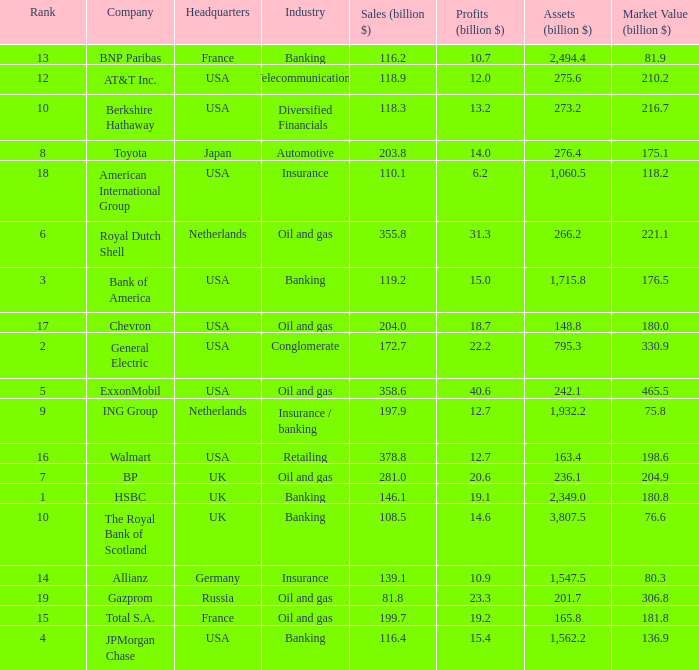What is the highest rank of a company that has 1,715.8 billion in assets?  3.0. 